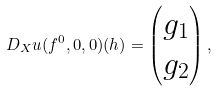Convert formula to latex. <formula><loc_0><loc_0><loc_500><loc_500>D _ { X } u ( f ^ { 0 } , 0 , 0 ) ( h ) = \left ( \begin{matrix} g _ { 1 } \\ g _ { 2 } \end{matrix} \right ) ,</formula> 